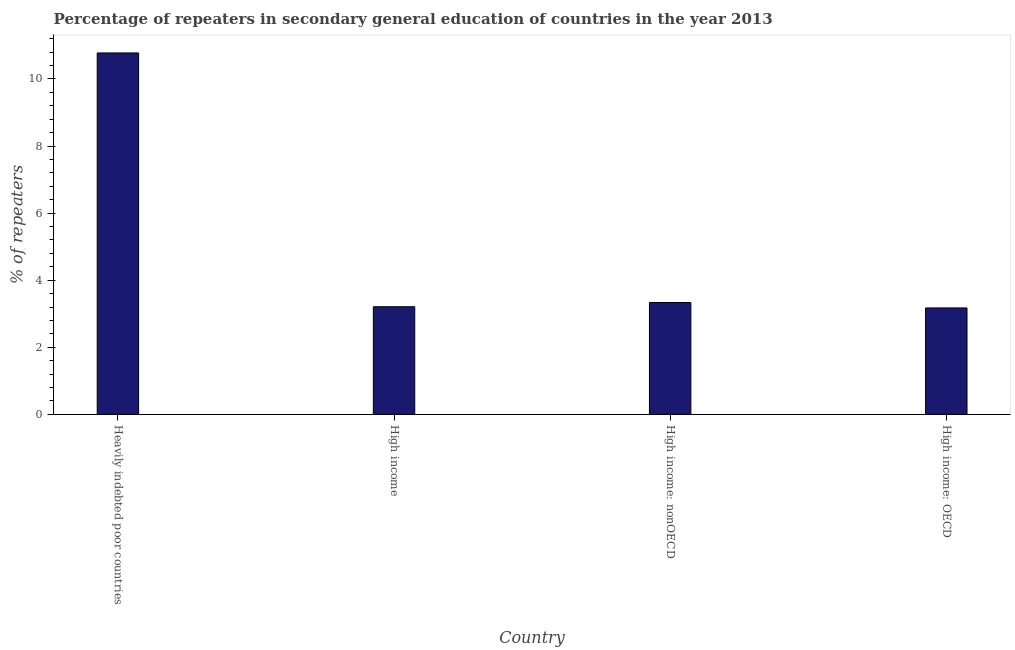Does the graph contain any zero values?
Provide a succinct answer. No. What is the title of the graph?
Offer a very short reply. Percentage of repeaters in secondary general education of countries in the year 2013. What is the label or title of the X-axis?
Your response must be concise. Country. What is the label or title of the Y-axis?
Make the answer very short. % of repeaters. What is the percentage of repeaters in Heavily indebted poor countries?
Your response must be concise. 10.77. Across all countries, what is the maximum percentage of repeaters?
Offer a very short reply. 10.77. Across all countries, what is the minimum percentage of repeaters?
Give a very brief answer. 3.17. In which country was the percentage of repeaters maximum?
Offer a terse response. Heavily indebted poor countries. In which country was the percentage of repeaters minimum?
Your answer should be compact. High income: OECD. What is the sum of the percentage of repeaters?
Make the answer very short. 20.49. What is the difference between the percentage of repeaters in Heavily indebted poor countries and High income: nonOECD?
Provide a succinct answer. 7.44. What is the average percentage of repeaters per country?
Your answer should be compact. 5.12. What is the median percentage of repeaters?
Offer a very short reply. 3.27. What is the ratio of the percentage of repeaters in Heavily indebted poor countries to that in High income: OECD?
Ensure brevity in your answer.  3.4. Is the difference between the percentage of repeaters in Heavily indebted poor countries and High income: OECD greater than the difference between any two countries?
Your answer should be compact. Yes. What is the difference between the highest and the second highest percentage of repeaters?
Your answer should be very brief. 7.44. How many bars are there?
Keep it short and to the point. 4. Are all the bars in the graph horizontal?
Your answer should be compact. No. How many countries are there in the graph?
Give a very brief answer. 4. What is the % of repeaters in Heavily indebted poor countries?
Ensure brevity in your answer.  10.77. What is the % of repeaters in High income?
Provide a succinct answer. 3.21. What is the % of repeaters of High income: nonOECD?
Offer a terse response. 3.33. What is the % of repeaters in High income: OECD?
Offer a very short reply. 3.17. What is the difference between the % of repeaters in Heavily indebted poor countries and High income?
Offer a very short reply. 7.57. What is the difference between the % of repeaters in Heavily indebted poor countries and High income: nonOECD?
Provide a short and direct response. 7.44. What is the difference between the % of repeaters in Heavily indebted poor countries and High income: OECD?
Make the answer very short. 7.6. What is the difference between the % of repeaters in High income and High income: nonOECD?
Your answer should be compact. -0.13. What is the difference between the % of repeaters in High income and High income: OECD?
Give a very brief answer. 0.04. What is the difference between the % of repeaters in High income: nonOECD and High income: OECD?
Offer a terse response. 0.16. What is the ratio of the % of repeaters in Heavily indebted poor countries to that in High income?
Make the answer very short. 3.36. What is the ratio of the % of repeaters in Heavily indebted poor countries to that in High income: nonOECD?
Give a very brief answer. 3.23. What is the ratio of the % of repeaters in Heavily indebted poor countries to that in High income: OECD?
Ensure brevity in your answer.  3.4. What is the ratio of the % of repeaters in High income to that in High income: nonOECD?
Give a very brief answer. 0.96. What is the ratio of the % of repeaters in High income: nonOECD to that in High income: OECD?
Make the answer very short. 1.05. 